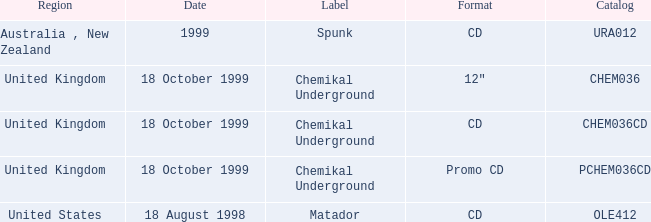What date is associated with the Spunk label? 1999.0. 